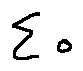<formula> <loc_0><loc_0><loc_500><loc_500>\sum o</formula> 